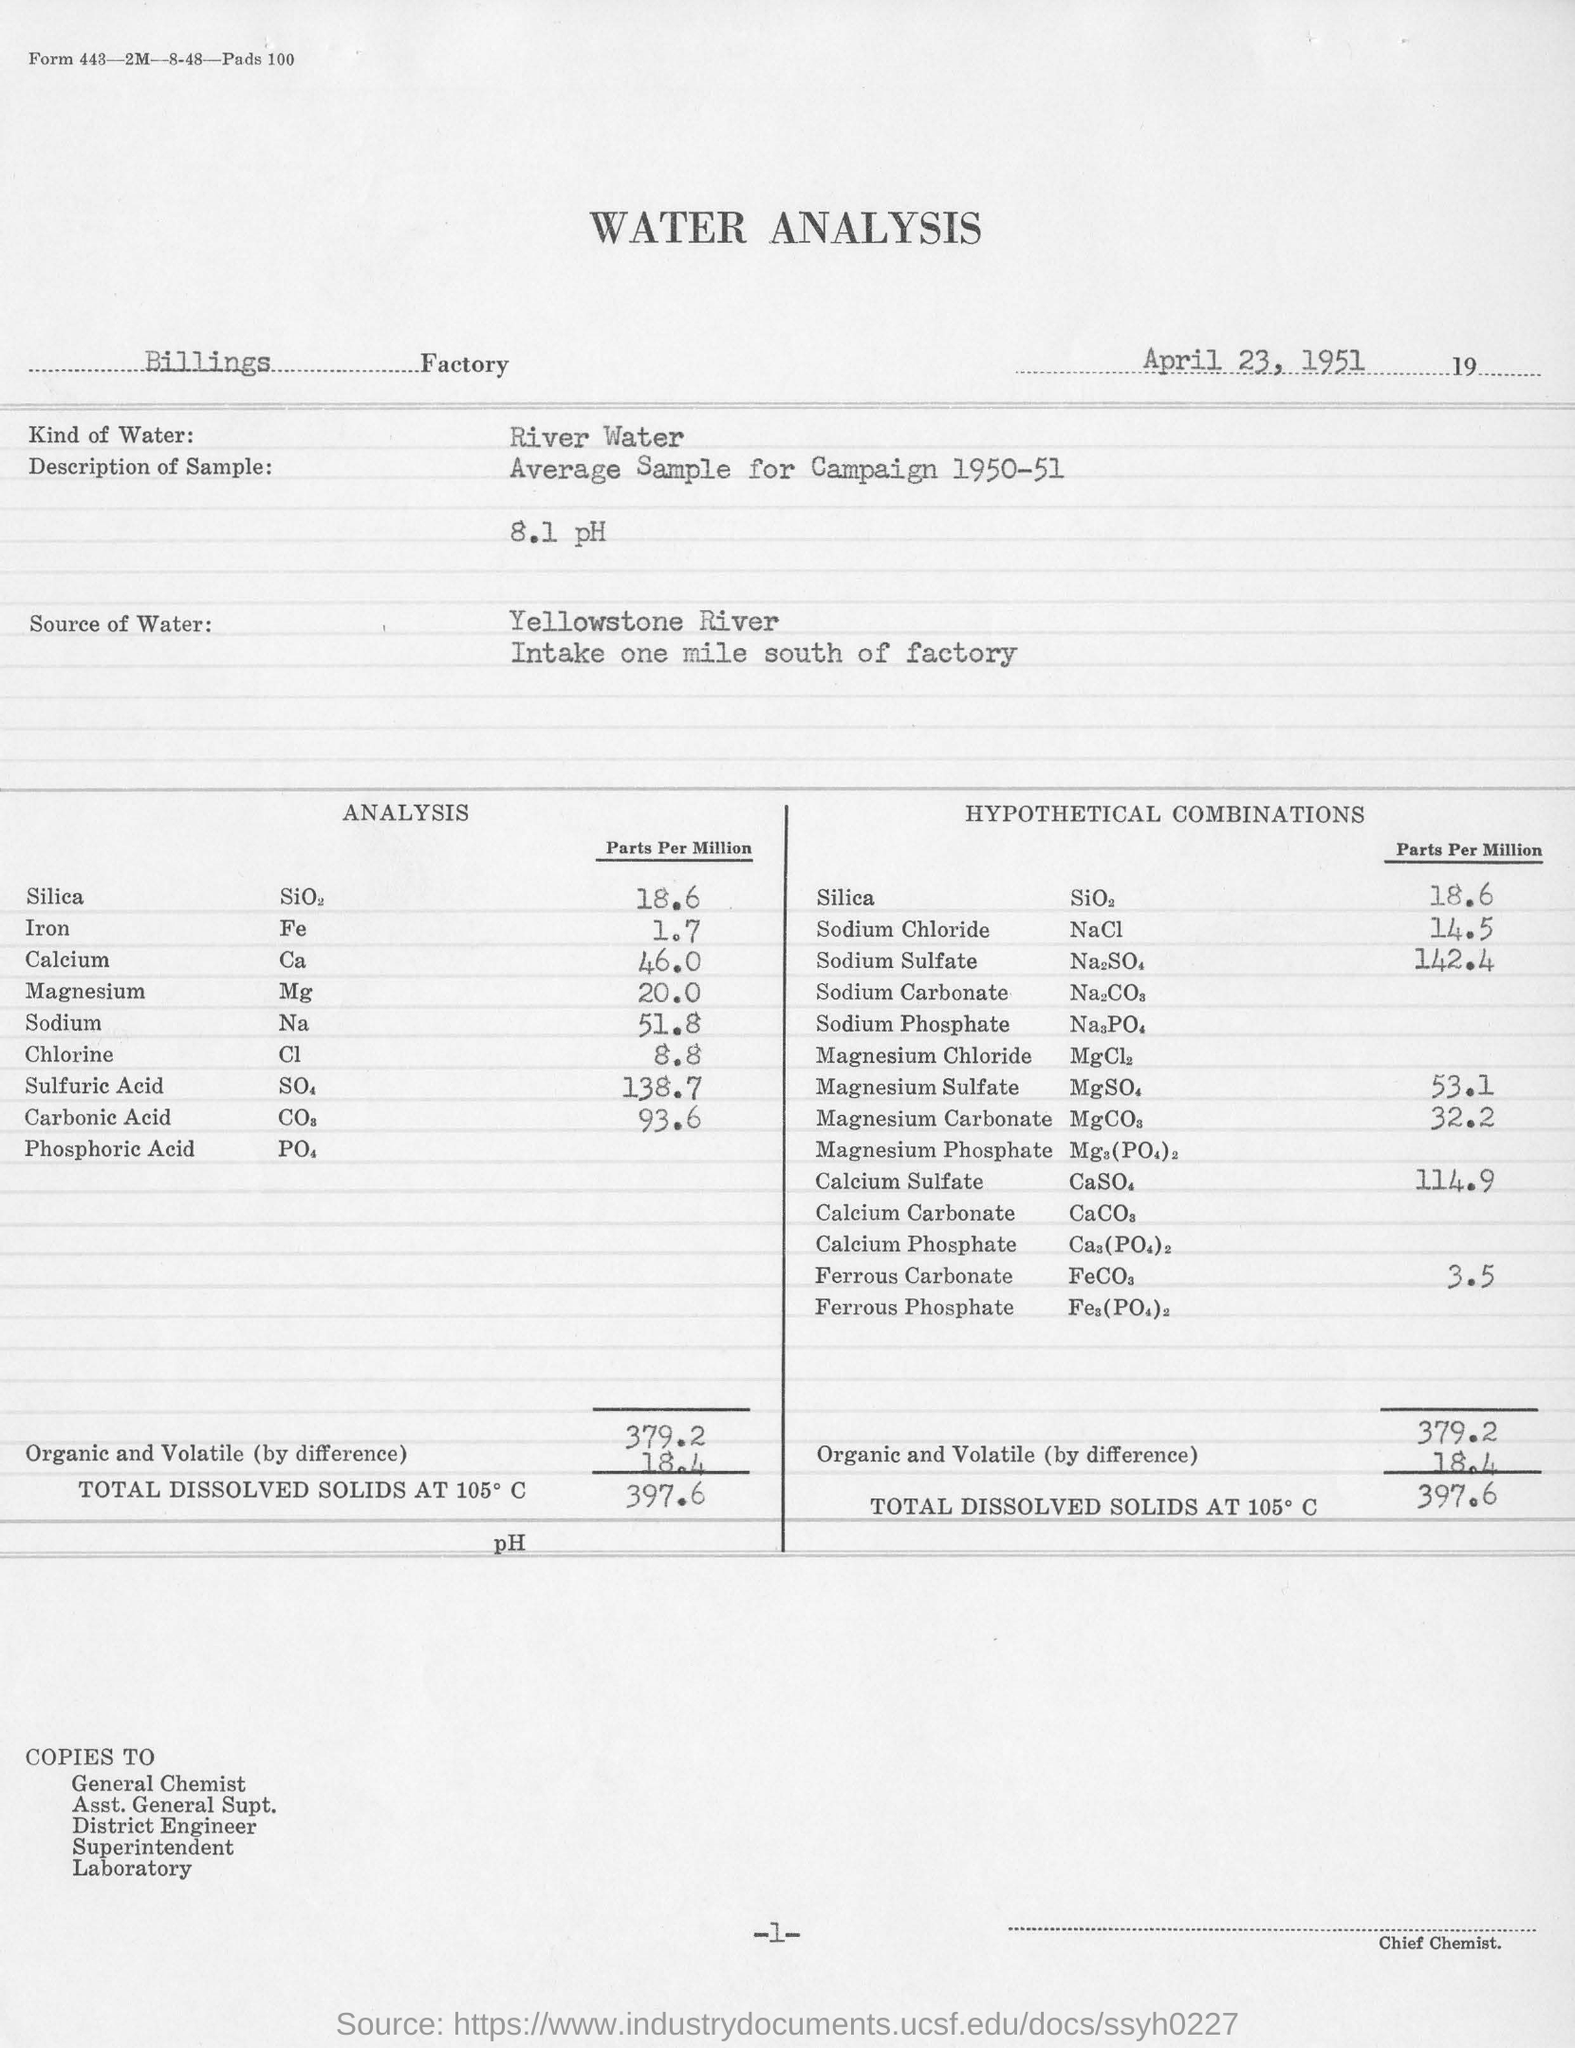In which Factory is the analysis conducted?
Make the answer very short. Billings. What kind of water is used for the analysis?
Make the answer very short. River water. What is the concentration of Silica in Parts Per Million in the analysis?
Make the answer very short. 18.6. What is the concentration of NaCL in Parts per Million in the analysis?
Provide a succinct answer. 14.5. What is the concentration of chlorine in Parts Per Million in the analysis?
Your answer should be compact. 8.8. What is the date mentioned in the water analysis?
Give a very brief answer. April 23, 1951. 